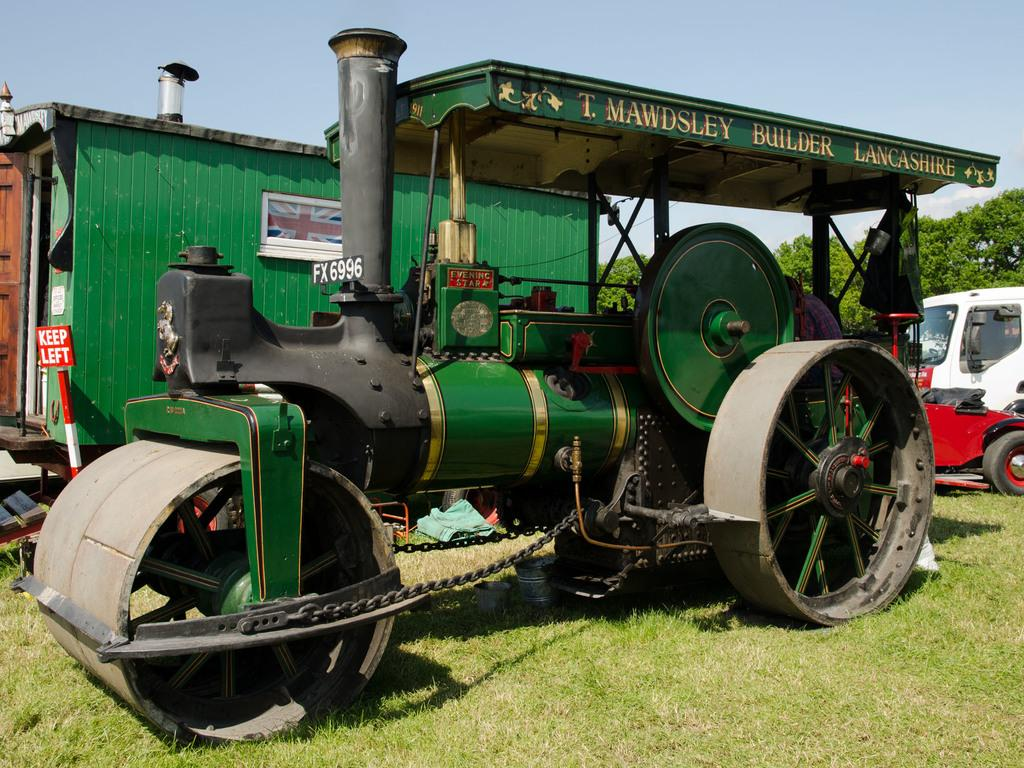How many vehicles can be seen in the image? There are two vehicles in the image. What is the surface on which the vehicles are placed? The vehicles are on a grass floor. What type of natural environment surrounds the vehicles? There are trees around the vehicles. What type of game is being played with the sack in the image? There is no sack or game present in the image; it features two vehicles on a grass floor with trees around them. 